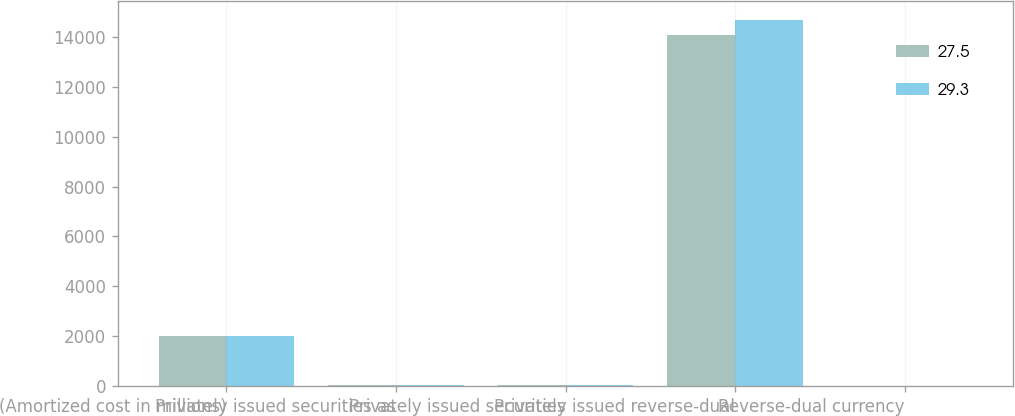Convert chart. <chart><loc_0><loc_0><loc_500><loc_500><stacked_bar_chart><ecel><fcel>(Amortized cost in millions)<fcel>Privately issued securities as<fcel>Privately issued securities<fcel>Privately issued reverse-dual<fcel>Reverse-dual currency<nl><fcel>27.5<fcel>2009<fcel>71.1<fcel>67.7<fcel>14070<fcel>27.5<nl><fcel>29.3<fcel>2008<fcel>72<fcel>68.3<fcel>14678<fcel>29.3<nl></chart> 